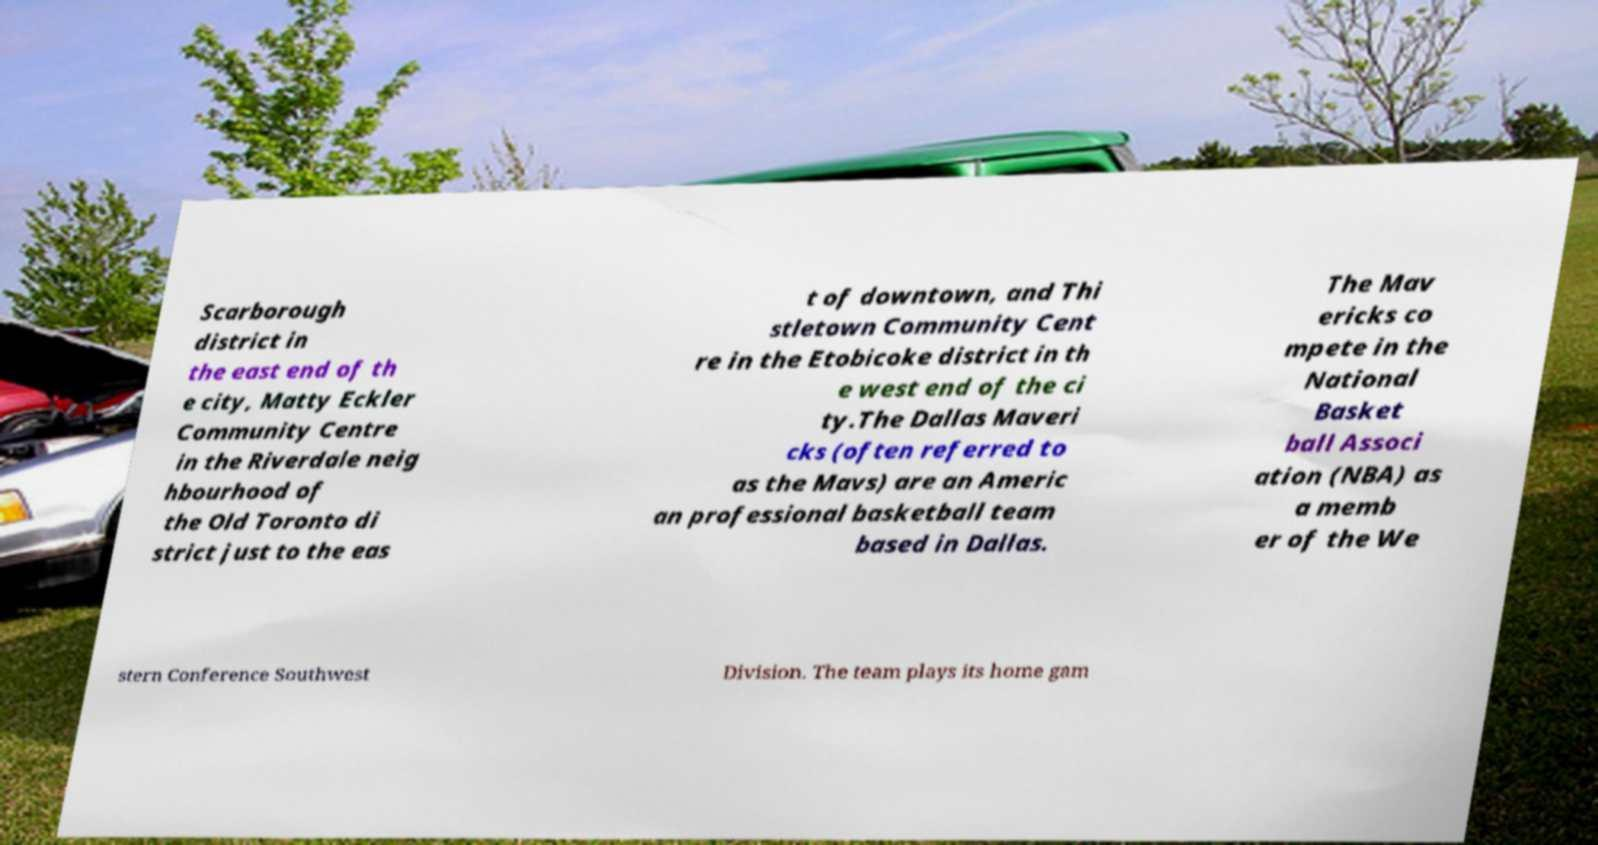What messages or text are displayed in this image? I need them in a readable, typed format. Scarborough district in the east end of th e city, Matty Eckler Community Centre in the Riverdale neig hbourhood of the Old Toronto di strict just to the eas t of downtown, and Thi stletown Community Cent re in the Etobicoke district in th e west end of the ci ty.The Dallas Maveri cks (often referred to as the Mavs) are an Americ an professional basketball team based in Dallas. The Mav ericks co mpete in the National Basket ball Associ ation (NBA) as a memb er of the We stern Conference Southwest Division. The team plays its home gam 